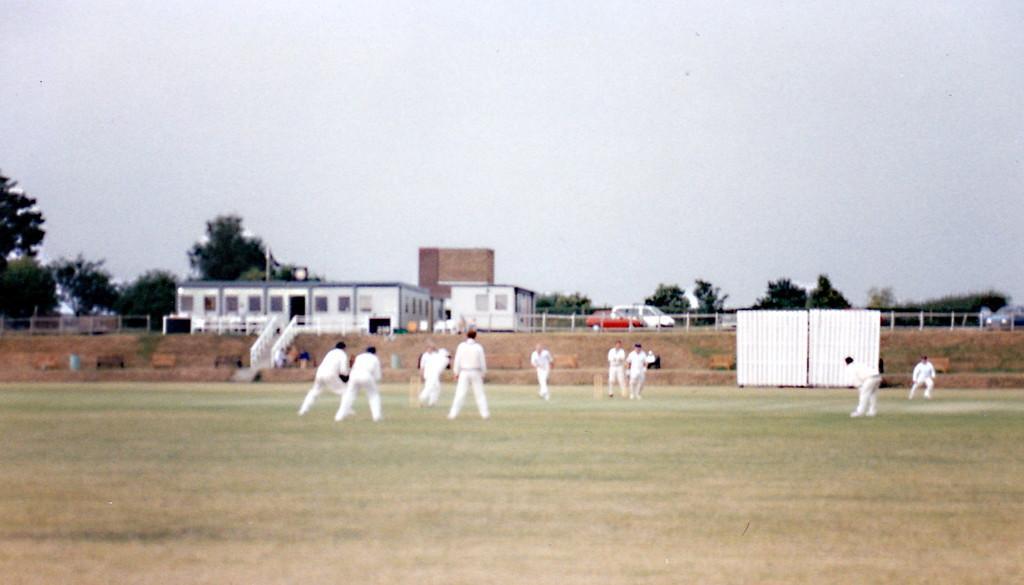Can you describe this image briefly? In this image there are a few people playing cricket in the ground, there are few people near the steps, a fence, houses, few people on the road, trees and the sky. 